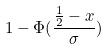<formula> <loc_0><loc_0><loc_500><loc_500>1 - \Phi ( \frac { \frac { 1 } { 2 } - x } { \sigma } )</formula> 